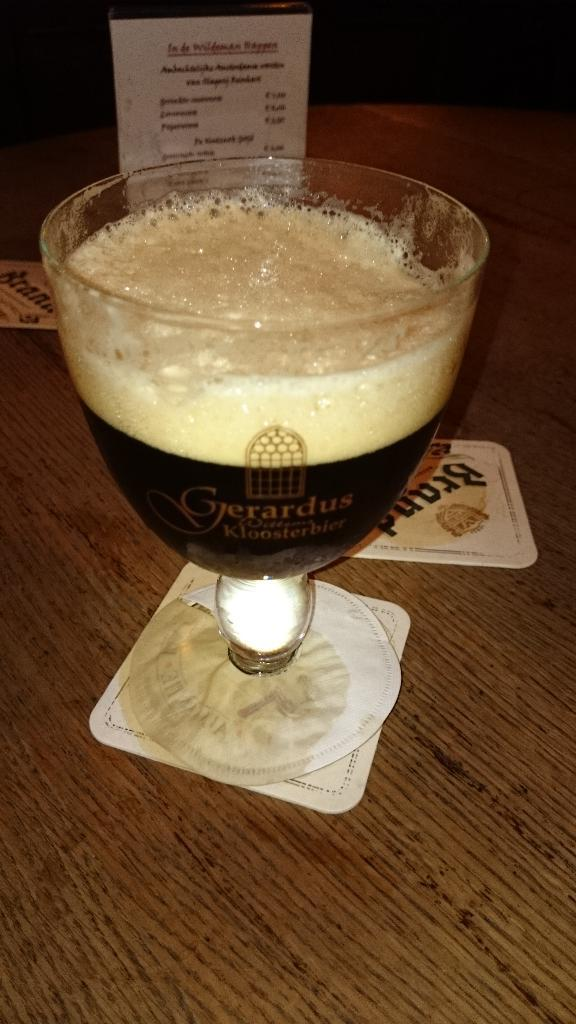What is contained in the glass that is visible in the image? There is a drink in the glass that is visible in the image. What type of furniture is at the bottom of the image? There is a table at the bottom of the image. What can be seen in the background of the image? There is a card in the background of the image. What religious symbol is present on the card in the background of the image? There is no religious symbol present on the card in the background of the image. What shape is the regret taking in the image? There is no regret present in the image, as it is not a physical object or emotion that can be depicted visually. 